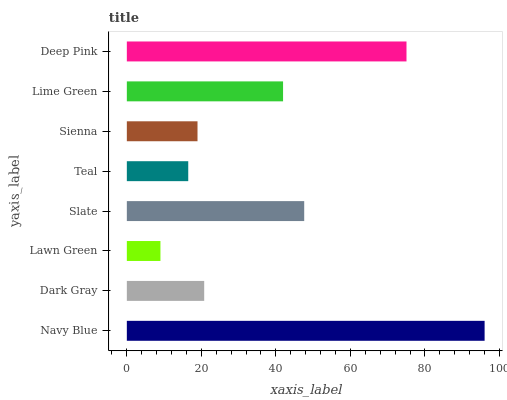Is Lawn Green the minimum?
Answer yes or no. Yes. Is Navy Blue the maximum?
Answer yes or no. Yes. Is Dark Gray the minimum?
Answer yes or no. No. Is Dark Gray the maximum?
Answer yes or no. No. Is Navy Blue greater than Dark Gray?
Answer yes or no. Yes. Is Dark Gray less than Navy Blue?
Answer yes or no. Yes. Is Dark Gray greater than Navy Blue?
Answer yes or no. No. Is Navy Blue less than Dark Gray?
Answer yes or no. No. Is Lime Green the high median?
Answer yes or no. Yes. Is Dark Gray the low median?
Answer yes or no. Yes. Is Deep Pink the high median?
Answer yes or no. No. Is Lime Green the low median?
Answer yes or no. No. 